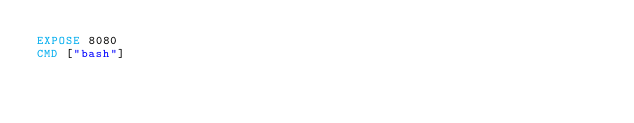<code> <loc_0><loc_0><loc_500><loc_500><_Dockerfile_>EXPOSE 8080
CMD ["bash"]
</code> 